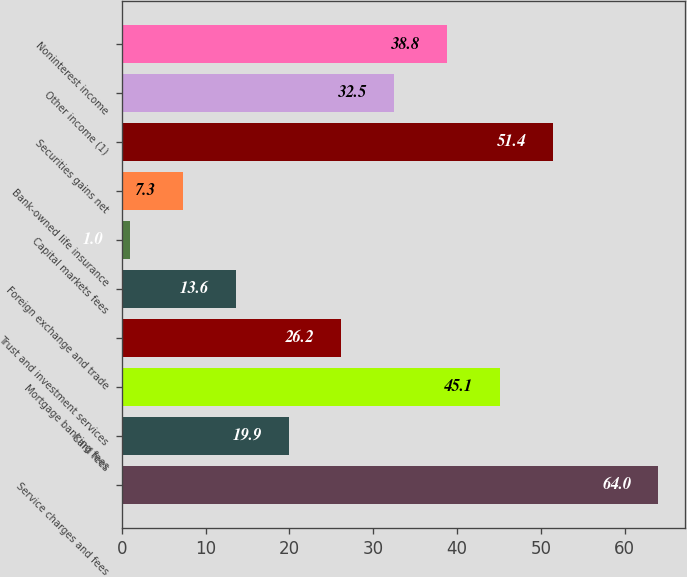Convert chart. <chart><loc_0><loc_0><loc_500><loc_500><bar_chart><fcel>Service charges and fees<fcel>Card fees<fcel>Mortgage banking fees<fcel>Trust and investment services<fcel>Foreign exchange and trade<fcel>Capital markets fees<fcel>Bank-owned life insurance<fcel>Securities gains net<fcel>Other income (1)<fcel>Noninterest income<nl><fcel>64<fcel>19.9<fcel>45.1<fcel>26.2<fcel>13.6<fcel>1<fcel>7.3<fcel>51.4<fcel>32.5<fcel>38.8<nl></chart> 